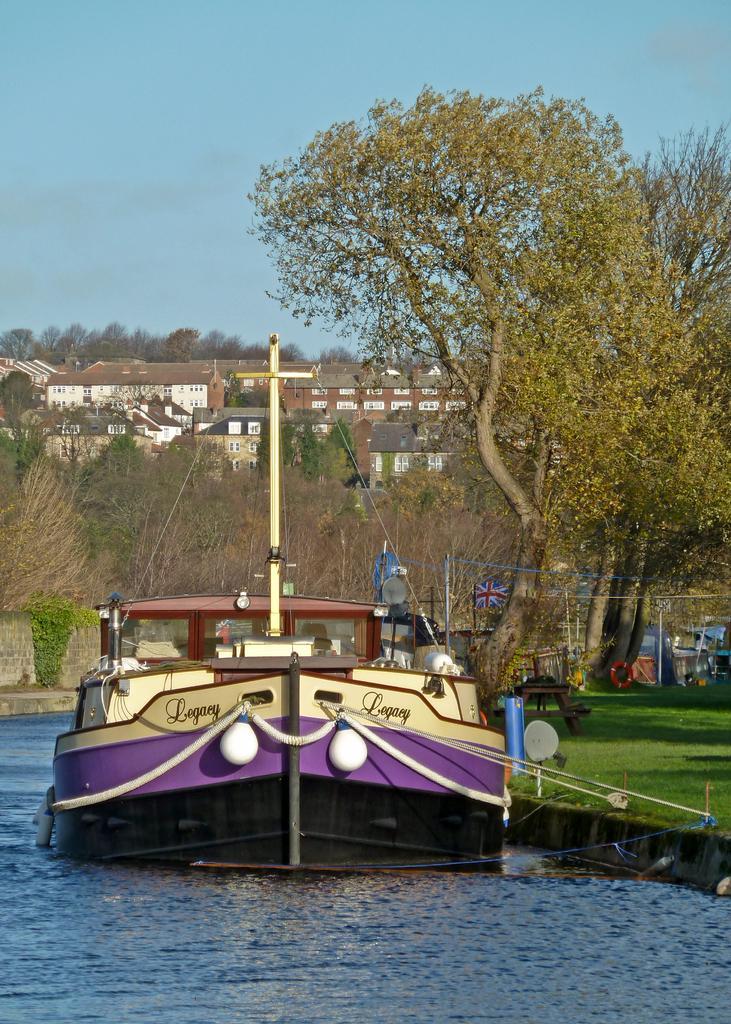Could you give a brief overview of what you see in this image? In this image we can see a boat with ropes is placed in the water. In the background, we can see a flag on a pole, group of trees, buildings and the sky. 